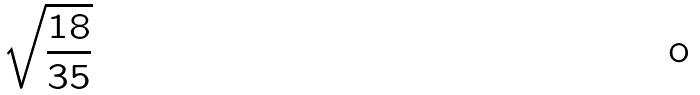<formula> <loc_0><loc_0><loc_500><loc_500>\sqrt { \frac { 1 8 } { 3 5 } }</formula> 